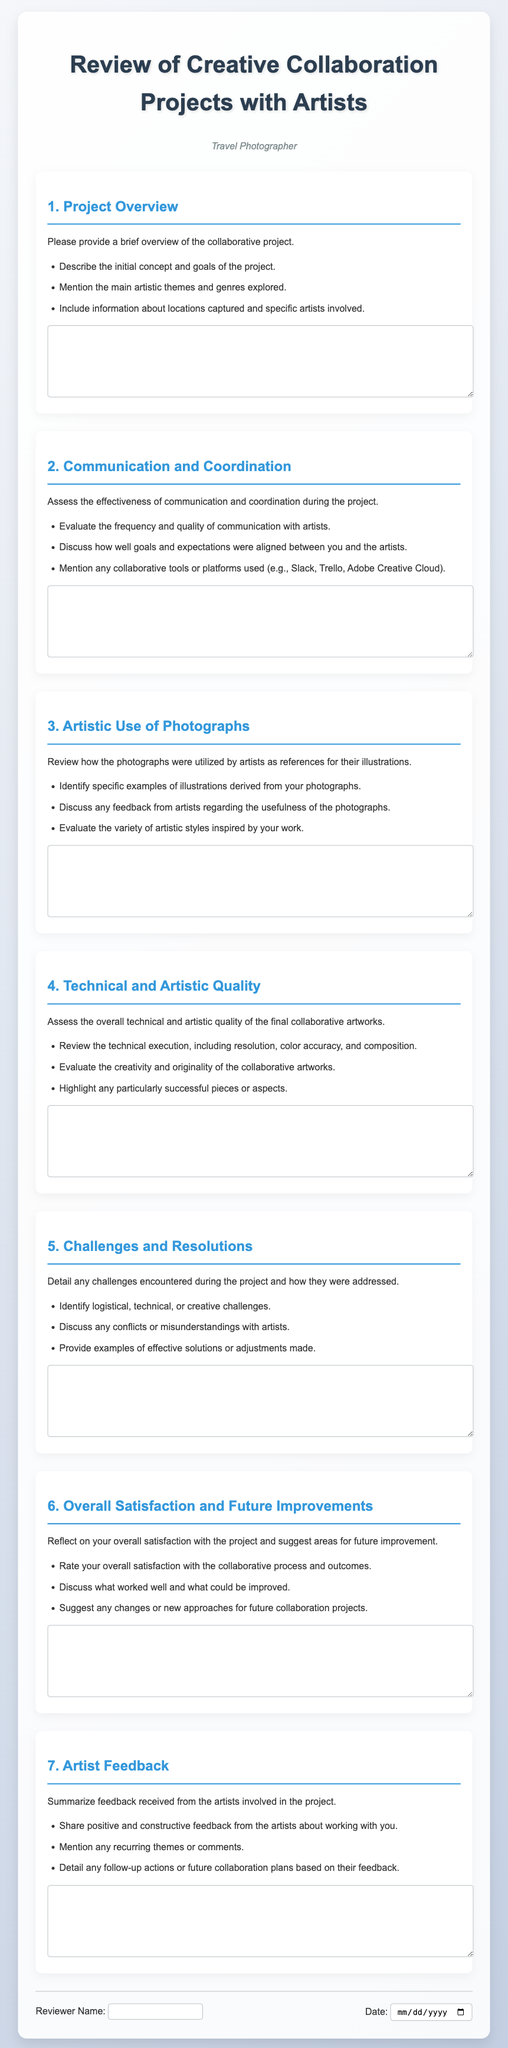What is the title of the document? The title of the document is clearly stated at the top of the rendered page.
Answer: Review of Creative Collaboration Projects with Artists How many main sections are there in the form? The form consists of multiple questions covering various aspects, each represented as a section.
Answer: 7 What is the purpose of the "Project Overview" section? The section aims to gather details regarding the project's initial concept and goals, along with artistic themes and involved artists.
Answer: To provide an overview of the collaborative project Which communication platforms are mentioned for collaboration? The document lists specific tools that are used for communication during the project.
Answer: Slack, Trello, Adobe Creative Cloud What is requested in the "Challenges and Resolutions" section? This section is designed to collect information about any encountered challenges and the approaches taken to resolve them.
Answer: Detail challenges and resolutions What does the "Overall Satisfaction" section ask for? This section seeks feedback on the reviewer's satisfaction with the collaborative process and suggestions for improvements.
Answer: Rate satisfaction and suggest improvements What type of feedback is summarized in the "Artist Feedback" section? The section focuses on sharing feedback received from artists regarding their collaboration experience.
Answer: Positive and constructive feedback In which part of the document is the reviewer’s name collected? The reviewer's name is collected in a specific area towards the end of the document.
Answer: Footer section 